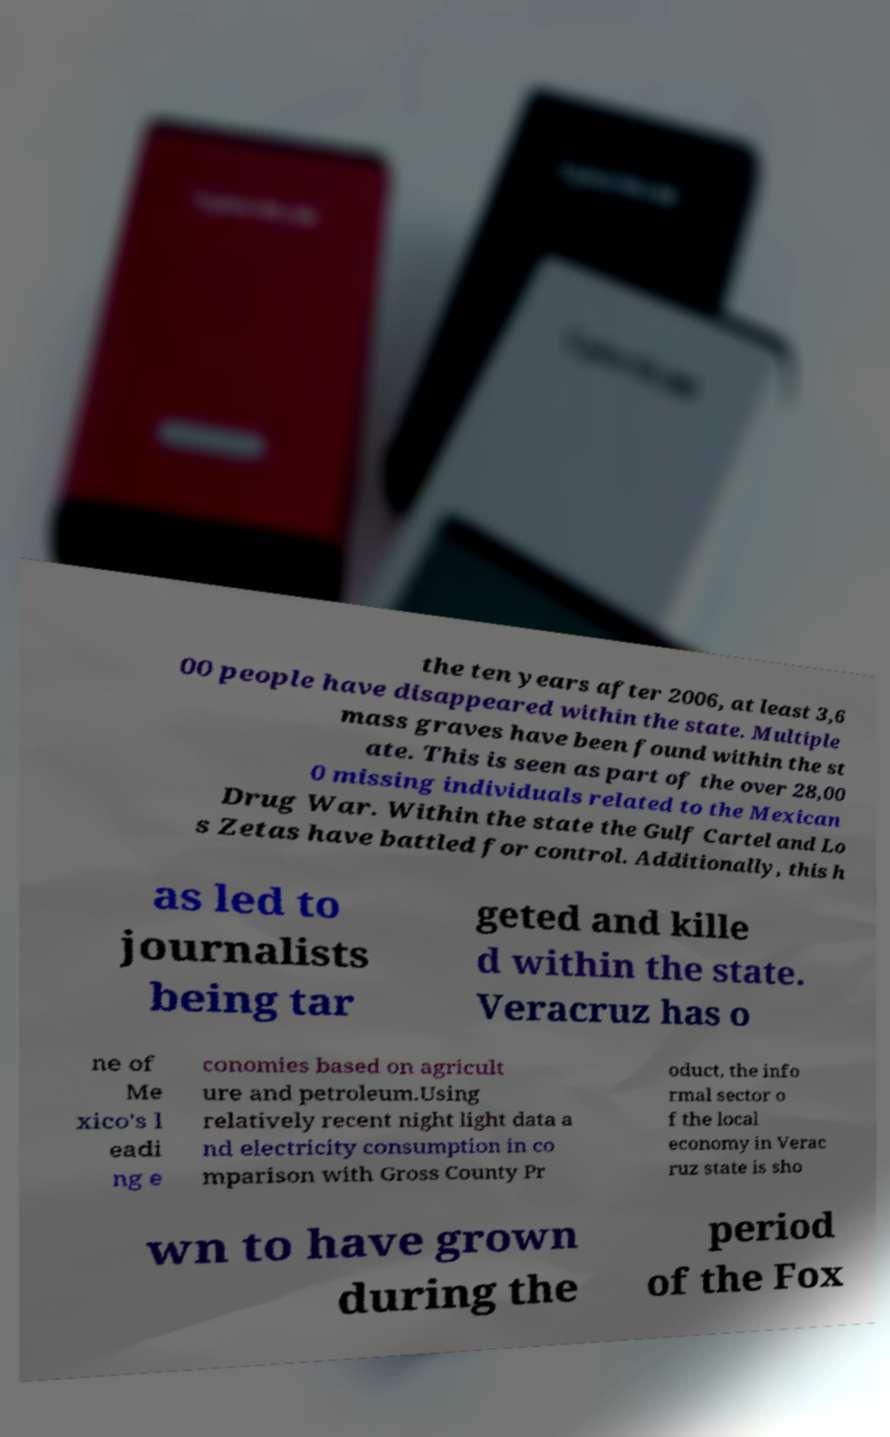For documentation purposes, I need the text within this image transcribed. Could you provide that? the ten years after 2006, at least 3,6 00 people have disappeared within the state. Multiple mass graves have been found within the st ate. This is seen as part of the over 28,00 0 missing individuals related to the Mexican Drug War. Within the state the Gulf Cartel and Lo s Zetas have battled for control. Additionally, this h as led to journalists being tar geted and kille d within the state. Veracruz has o ne of Me xico's l eadi ng e conomies based on agricult ure and petroleum.Using relatively recent night light data a nd electricity consumption in co mparison with Gross County Pr oduct, the info rmal sector o f the local economy in Verac ruz state is sho wn to have grown during the period of the Fox 